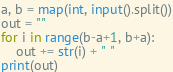<code> <loc_0><loc_0><loc_500><loc_500><_Python_>a, b = map(int, input().split())
out = ""
for i in range(b-a+1, b+a):
    out += str(i) + " "
print(out)</code> 